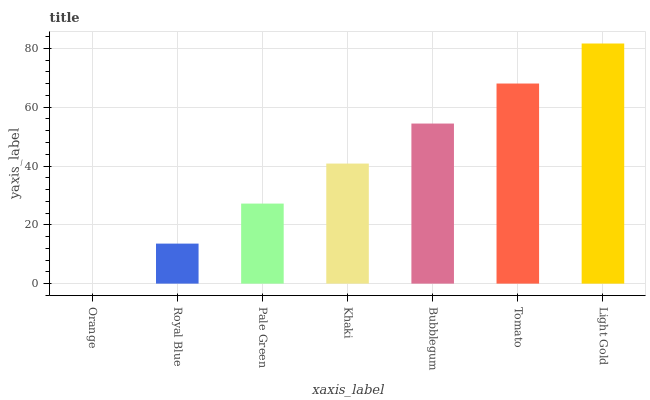Is Orange the minimum?
Answer yes or no. Yes. Is Light Gold the maximum?
Answer yes or no. Yes. Is Royal Blue the minimum?
Answer yes or no. No. Is Royal Blue the maximum?
Answer yes or no. No. Is Royal Blue greater than Orange?
Answer yes or no. Yes. Is Orange less than Royal Blue?
Answer yes or no. Yes. Is Orange greater than Royal Blue?
Answer yes or no. No. Is Royal Blue less than Orange?
Answer yes or no. No. Is Khaki the high median?
Answer yes or no. Yes. Is Khaki the low median?
Answer yes or no. Yes. Is Light Gold the high median?
Answer yes or no. No. Is Light Gold the low median?
Answer yes or no. No. 